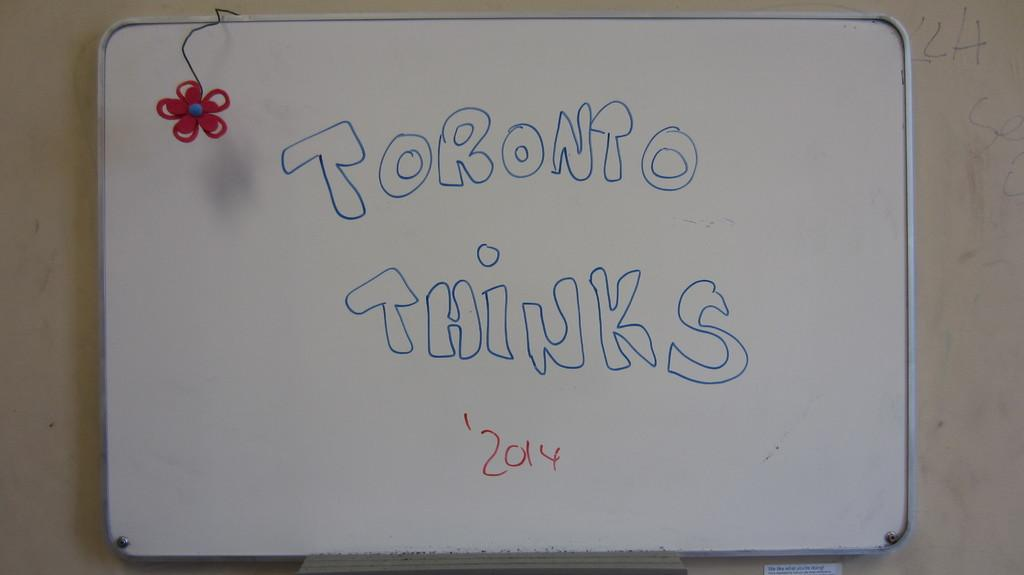<image>
Share a concise interpretation of the image provided. A whiteboard with a flower at the top reads "Toronto Thinks '2014" 